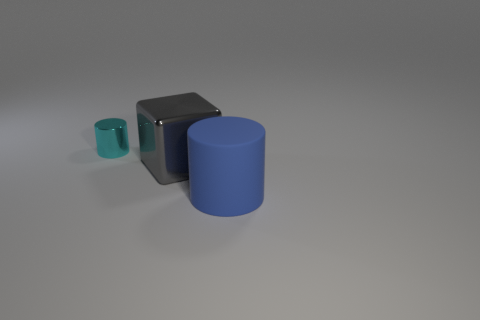Subtract all cylinders. How many objects are left? 1 Add 2 large blue rubber cylinders. How many objects exist? 5 Subtract 0 cyan cubes. How many objects are left? 3 Subtract 1 cylinders. How many cylinders are left? 1 Subtract all yellow blocks. Subtract all yellow cylinders. How many blocks are left? 1 Subtract all cyan spheres. How many cyan cylinders are left? 1 Subtract all metallic blocks. Subtract all large blue metallic things. How many objects are left? 2 Add 2 gray metal things. How many gray metal things are left? 3 Add 1 large yellow objects. How many large yellow objects exist? 1 